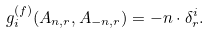<formula> <loc_0><loc_0><loc_500><loc_500>\ g _ { i } ^ { ( f ) } ( A _ { n , r } , A _ { - n , r } ) = - n \cdot \delta _ { r } ^ { i } .</formula> 